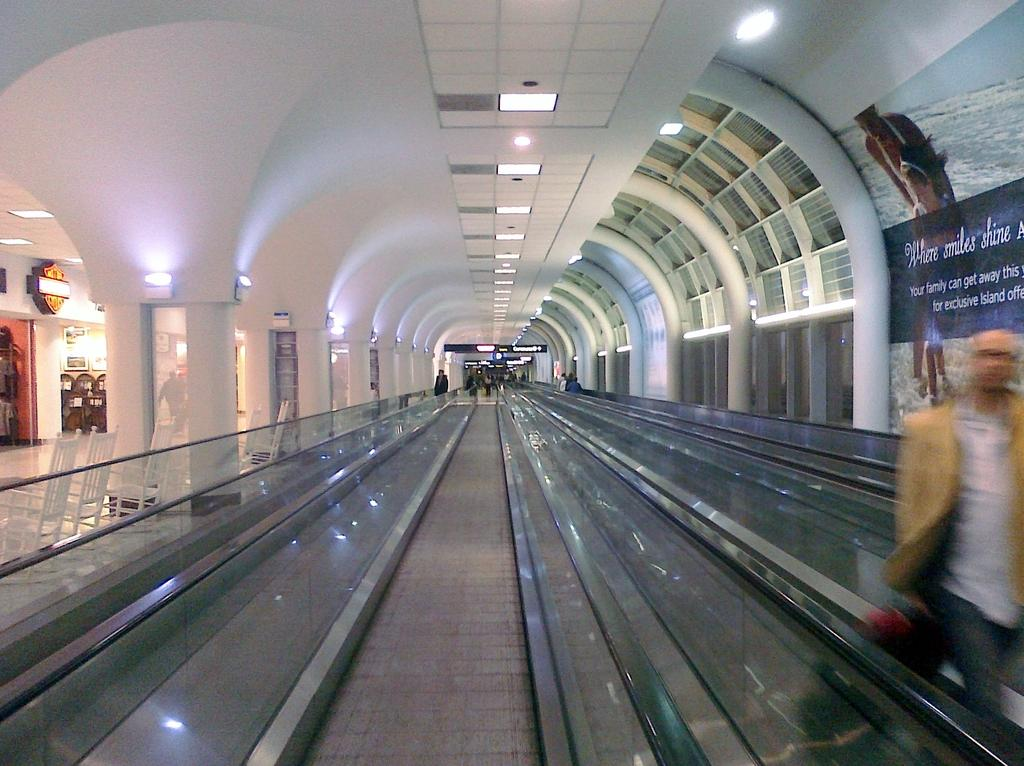Provide a one-sentence caption for the provided image. A series of moving walkways is in the center while a banner to the right advertises where smiles shine. 